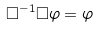<formula> <loc_0><loc_0><loc_500><loc_500>\square ^ { - 1 } \square \varphi = \varphi</formula> 